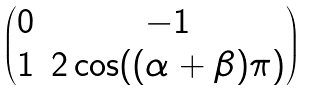<formula> <loc_0><loc_0><loc_500><loc_500>\begin{pmatrix} 0 & - 1 \\ 1 & 2 \cos ( ( \alpha + \beta ) \pi ) \end{pmatrix}</formula> 